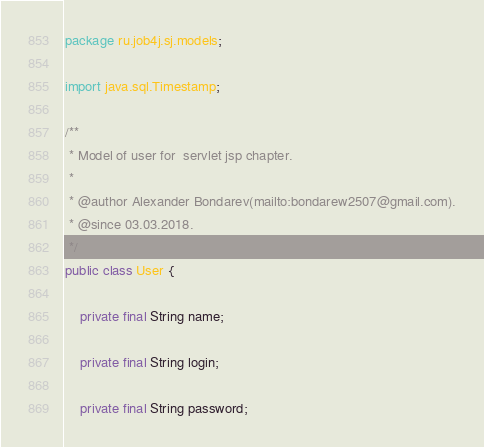<code> <loc_0><loc_0><loc_500><loc_500><_Java_>package ru.job4j.sj.models;

import java.sql.Timestamp;

/**
 * Model of user for  servlet jsp chapter.
 *
 * @author Alexander Bondarev(mailto:bondarew2507@gmail.com).
 * @since 03.03.2018.
 */
public class User {

    private final String name;

    private final String login;

    private final String password;
</code> 